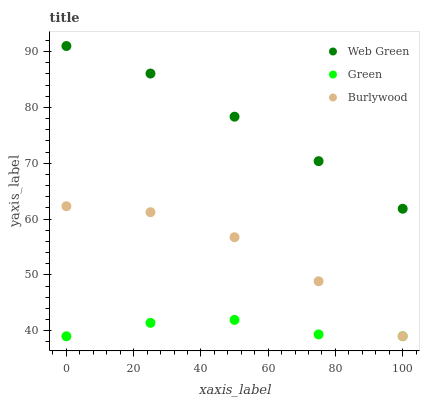Does Green have the minimum area under the curve?
Answer yes or no. Yes. Does Web Green have the maximum area under the curve?
Answer yes or no. Yes. Does Web Green have the minimum area under the curve?
Answer yes or no. No. Does Green have the maximum area under the curve?
Answer yes or no. No. Is Web Green the smoothest?
Answer yes or no. Yes. Is Burlywood the roughest?
Answer yes or no. Yes. Is Green the smoothest?
Answer yes or no. No. Is Green the roughest?
Answer yes or no. No. Does Burlywood have the lowest value?
Answer yes or no. Yes. Does Web Green have the lowest value?
Answer yes or no. No. Does Web Green have the highest value?
Answer yes or no. Yes. Does Green have the highest value?
Answer yes or no. No. Is Green less than Web Green?
Answer yes or no. Yes. Is Web Green greater than Burlywood?
Answer yes or no. Yes. Does Green intersect Burlywood?
Answer yes or no. Yes. Is Green less than Burlywood?
Answer yes or no. No. Is Green greater than Burlywood?
Answer yes or no. No. Does Green intersect Web Green?
Answer yes or no. No. 